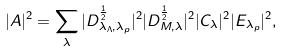Convert formula to latex. <formula><loc_0><loc_0><loc_500><loc_500>| A | ^ { 2 } = \sum _ { \lambda } | D ^ { \frac { 1 } { 2 } } _ { \lambda _ { \Lambda } , \lambda _ { p } } | ^ { 2 } | D ^ { \frac { 1 } { 2 } } _ { M , \lambda } | ^ { 2 } | C _ { \lambda } | ^ { 2 } | E _ { \lambda _ { p } } | ^ { 2 } ,</formula> 